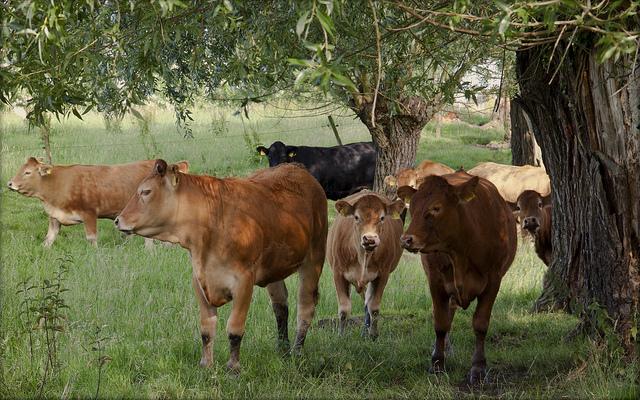Where are the trees?
Answer briefly. Next to cows. Are these animal all looking the same way?
Quick response, please. No. Which cow stands out the most?
Be succinct. Black one. What color are the cows?
Keep it brief. Brown. Are these cows the same age?
Quick response, please. Yes. How many cows are in the scene?
Answer briefly. 7. Is this animal a male or a female?
Give a very brief answer. Female. 